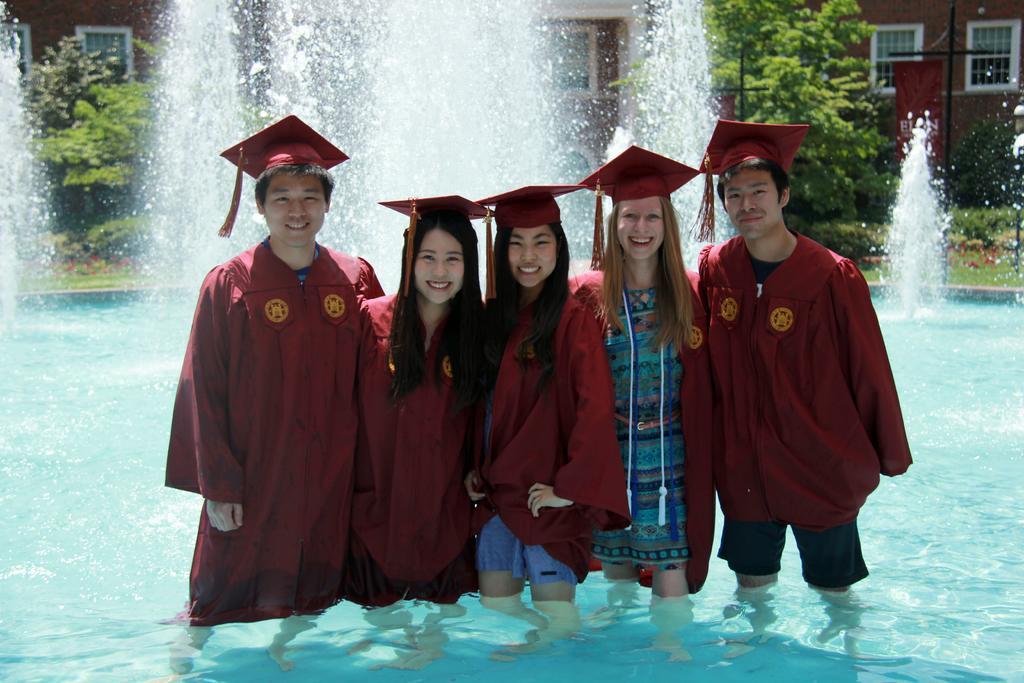In one or two sentences, can you explain what this image depicts? In this picture I can observe five members standing in the pool. All of them are wearing academic dresses which are in maroon color. They are smiling. Behind them I can observe water fountain. In the background there are trees and a building. 